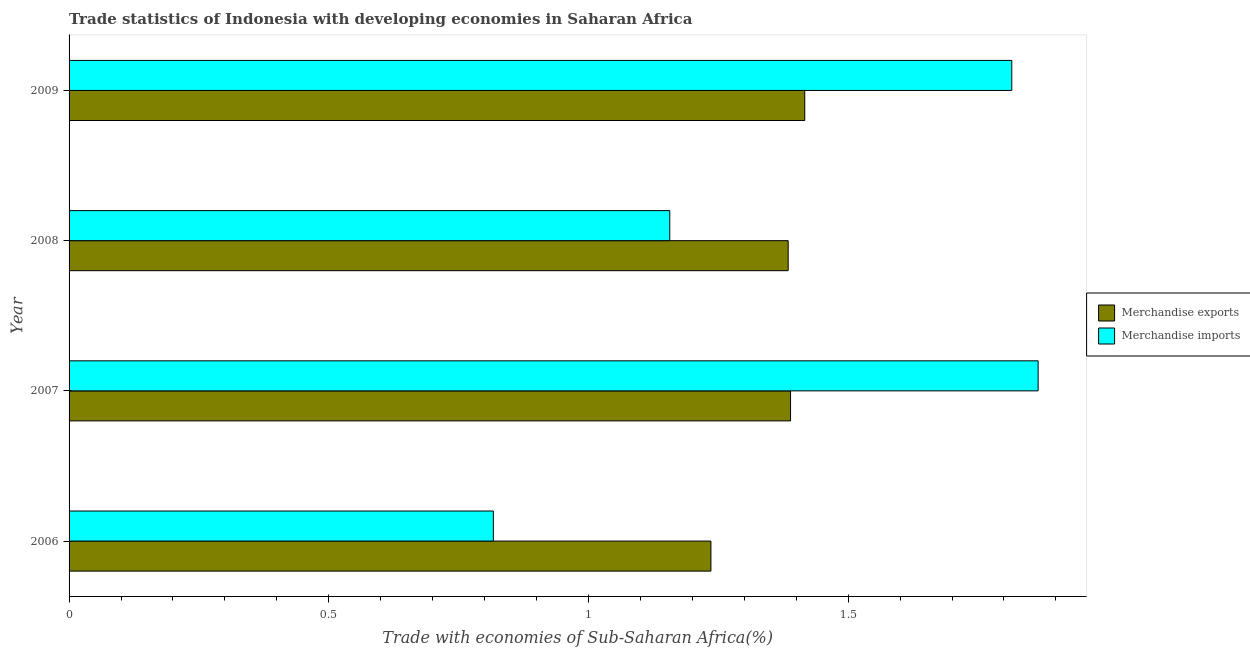How many groups of bars are there?
Your answer should be very brief. 4. Are the number of bars on each tick of the Y-axis equal?
Offer a terse response. Yes. How many bars are there on the 2nd tick from the top?
Offer a very short reply. 2. What is the label of the 3rd group of bars from the top?
Give a very brief answer. 2007. In how many cases, is the number of bars for a given year not equal to the number of legend labels?
Make the answer very short. 0. What is the merchandise exports in 2006?
Offer a terse response. 1.24. Across all years, what is the maximum merchandise imports?
Make the answer very short. 1.87. Across all years, what is the minimum merchandise imports?
Give a very brief answer. 0.82. In which year was the merchandise exports minimum?
Your answer should be compact. 2006. What is the total merchandise imports in the graph?
Your answer should be very brief. 5.65. What is the difference between the merchandise exports in 2006 and that in 2007?
Ensure brevity in your answer.  -0.15. What is the difference between the merchandise imports in 2009 and the merchandise exports in 2007?
Make the answer very short. 0.43. What is the average merchandise imports per year?
Keep it short and to the point. 1.41. In the year 2006, what is the difference between the merchandise imports and merchandise exports?
Provide a succinct answer. -0.42. What is the ratio of the merchandise imports in 2006 to that in 2008?
Your response must be concise. 0.71. What is the difference between the highest and the second highest merchandise exports?
Your answer should be compact. 0.03. What is the difference between the highest and the lowest merchandise exports?
Provide a succinct answer. 0.18. In how many years, is the merchandise exports greater than the average merchandise exports taken over all years?
Your response must be concise. 3. Is the sum of the merchandise exports in 2007 and 2008 greater than the maximum merchandise imports across all years?
Provide a short and direct response. Yes. What does the 2nd bar from the top in 2006 represents?
Your answer should be very brief. Merchandise exports. What does the 1st bar from the bottom in 2006 represents?
Offer a terse response. Merchandise exports. How many bars are there?
Ensure brevity in your answer.  8. Are all the bars in the graph horizontal?
Provide a succinct answer. Yes. Are the values on the major ticks of X-axis written in scientific E-notation?
Your response must be concise. No. Where does the legend appear in the graph?
Provide a succinct answer. Center right. How are the legend labels stacked?
Your answer should be very brief. Vertical. What is the title of the graph?
Keep it short and to the point. Trade statistics of Indonesia with developing economies in Saharan Africa. What is the label or title of the X-axis?
Offer a very short reply. Trade with economies of Sub-Saharan Africa(%). What is the label or title of the Y-axis?
Give a very brief answer. Year. What is the Trade with economies of Sub-Saharan Africa(%) in Merchandise exports in 2006?
Your answer should be very brief. 1.24. What is the Trade with economies of Sub-Saharan Africa(%) of Merchandise imports in 2006?
Offer a terse response. 0.82. What is the Trade with economies of Sub-Saharan Africa(%) of Merchandise exports in 2007?
Provide a short and direct response. 1.39. What is the Trade with economies of Sub-Saharan Africa(%) in Merchandise imports in 2007?
Give a very brief answer. 1.87. What is the Trade with economies of Sub-Saharan Africa(%) of Merchandise exports in 2008?
Keep it short and to the point. 1.38. What is the Trade with economies of Sub-Saharan Africa(%) of Merchandise imports in 2008?
Offer a very short reply. 1.16. What is the Trade with economies of Sub-Saharan Africa(%) of Merchandise exports in 2009?
Offer a very short reply. 1.42. What is the Trade with economies of Sub-Saharan Africa(%) in Merchandise imports in 2009?
Offer a very short reply. 1.82. Across all years, what is the maximum Trade with economies of Sub-Saharan Africa(%) of Merchandise exports?
Your answer should be very brief. 1.42. Across all years, what is the maximum Trade with economies of Sub-Saharan Africa(%) of Merchandise imports?
Your answer should be compact. 1.87. Across all years, what is the minimum Trade with economies of Sub-Saharan Africa(%) in Merchandise exports?
Your answer should be compact. 1.24. Across all years, what is the minimum Trade with economies of Sub-Saharan Africa(%) in Merchandise imports?
Keep it short and to the point. 0.82. What is the total Trade with economies of Sub-Saharan Africa(%) in Merchandise exports in the graph?
Provide a short and direct response. 5.43. What is the total Trade with economies of Sub-Saharan Africa(%) of Merchandise imports in the graph?
Your answer should be compact. 5.65. What is the difference between the Trade with economies of Sub-Saharan Africa(%) of Merchandise exports in 2006 and that in 2007?
Provide a succinct answer. -0.15. What is the difference between the Trade with economies of Sub-Saharan Africa(%) in Merchandise imports in 2006 and that in 2007?
Provide a succinct answer. -1.05. What is the difference between the Trade with economies of Sub-Saharan Africa(%) in Merchandise exports in 2006 and that in 2008?
Your answer should be very brief. -0.15. What is the difference between the Trade with economies of Sub-Saharan Africa(%) in Merchandise imports in 2006 and that in 2008?
Your answer should be compact. -0.34. What is the difference between the Trade with economies of Sub-Saharan Africa(%) of Merchandise exports in 2006 and that in 2009?
Your answer should be compact. -0.18. What is the difference between the Trade with economies of Sub-Saharan Africa(%) in Merchandise imports in 2006 and that in 2009?
Your answer should be compact. -1. What is the difference between the Trade with economies of Sub-Saharan Africa(%) of Merchandise exports in 2007 and that in 2008?
Ensure brevity in your answer.  0. What is the difference between the Trade with economies of Sub-Saharan Africa(%) of Merchandise imports in 2007 and that in 2008?
Make the answer very short. 0.71. What is the difference between the Trade with economies of Sub-Saharan Africa(%) of Merchandise exports in 2007 and that in 2009?
Give a very brief answer. -0.03. What is the difference between the Trade with economies of Sub-Saharan Africa(%) of Merchandise imports in 2007 and that in 2009?
Offer a very short reply. 0.05. What is the difference between the Trade with economies of Sub-Saharan Africa(%) in Merchandise exports in 2008 and that in 2009?
Offer a terse response. -0.03. What is the difference between the Trade with economies of Sub-Saharan Africa(%) of Merchandise imports in 2008 and that in 2009?
Give a very brief answer. -0.66. What is the difference between the Trade with economies of Sub-Saharan Africa(%) in Merchandise exports in 2006 and the Trade with economies of Sub-Saharan Africa(%) in Merchandise imports in 2007?
Provide a succinct answer. -0.63. What is the difference between the Trade with economies of Sub-Saharan Africa(%) in Merchandise exports in 2006 and the Trade with economies of Sub-Saharan Africa(%) in Merchandise imports in 2008?
Make the answer very short. 0.08. What is the difference between the Trade with economies of Sub-Saharan Africa(%) in Merchandise exports in 2006 and the Trade with economies of Sub-Saharan Africa(%) in Merchandise imports in 2009?
Provide a succinct answer. -0.58. What is the difference between the Trade with economies of Sub-Saharan Africa(%) in Merchandise exports in 2007 and the Trade with economies of Sub-Saharan Africa(%) in Merchandise imports in 2008?
Offer a terse response. 0.23. What is the difference between the Trade with economies of Sub-Saharan Africa(%) in Merchandise exports in 2007 and the Trade with economies of Sub-Saharan Africa(%) in Merchandise imports in 2009?
Provide a short and direct response. -0.43. What is the difference between the Trade with economies of Sub-Saharan Africa(%) in Merchandise exports in 2008 and the Trade with economies of Sub-Saharan Africa(%) in Merchandise imports in 2009?
Provide a short and direct response. -0.43. What is the average Trade with economies of Sub-Saharan Africa(%) in Merchandise exports per year?
Make the answer very short. 1.36. What is the average Trade with economies of Sub-Saharan Africa(%) in Merchandise imports per year?
Your answer should be compact. 1.41. In the year 2006, what is the difference between the Trade with economies of Sub-Saharan Africa(%) of Merchandise exports and Trade with economies of Sub-Saharan Africa(%) of Merchandise imports?
Give a very brief answer. 0.42. In the year 2007, what is the difference between the Trade with economies of Sub-Saharan Africa(%) in Merchandise exports and Trade with economies of Sub-Saharan Africa(%) in Merchandise imports?
Offer a terse response. -0.48. In the year 2008, what is the difference between the Trade with economies of Sub-Saharan Africa(%) of Merchandise exports and Trade with economies of Sub-Saharan Africa(%) of Merchandise imports?
Your response must be concise. 0.23. In the year 2009, what is the difference between the Trade with economies of Sub-Saharan Africa(%) in Merchandise exports and Trade with economies of Sub-Saharan Africa(%) in Merchandise imports?
Provide a short and direct response. -0.4. What is the ratio of the Trade with economies of Sub-Saharan Africa(%) of Merchandise exports in 2006 to that in 2007?
Offer a terse response. 0.89. What is the ratio of the Trade with economies of Sub-Saharan Africa(%) of Merchandise imports in 2006 to that in 2007?
Make the answer very short. 0.44. What is the ratio of the Trade with economies of Sub-Saharan Africa(%) of Merchandise exports in 2006 to that in 2008?
Offer a very short reply. 0.89. What is the ratio of the Trade with economies of Sub-Saharan Africa(%) of Merchandise imports in 2006 to that in 2008?
Keep it short and to the point. 0.71. What is the ratio of the Trade with economies of Sub-Saharan Africa(%) of Merchandise exports in 2006 to that in 2009?
Give a very brief answer. 0.87. What is the ratio of the Trade with economies of Sub-Saharan Africa(%) in Merchandise imports in 2006 to that in 2009?
Keep it short and to the point. 0.45. What is the ratio of the Trade with economies of Sub-Saharan Africa(%) in Merchandise exports in 2007 to that in 2008?
Keep it short and to the point. 1. What is the ratio of the Trade with economies of Sub-Saharan Africa(%) in Merchandise imports in 2007 to that in 2008?
Offer a terse response. 1.61. What is the ratio of the Trade with economies of Sub-Saharan Africa(%) in Merchandise exports in 2007 to that in 2009?
Ensure brevity in your answer.  0.98. What is the ratio of the Trade with economies of Sub-Saharan Africa(%) of Merchandise imports in 2007 to that in 2009?
Provide a short and direct response. 1.03. What is the ratio of the Trade with economies of Sub-Saharan Africa(%) in Merchandise exports in 2008 to that in 2009?
Your response must be concise. 0.98. What is the ratio of the Trade with economies of Sub-Saharan Africa(%) in Merchandise imports in 2008 to that in 2009?
Offer a very short reply. 0.64. What is the difference between the highest and the second highest Trade with economies of Sub-Saharan Africa(%) in Merchandise exports?
Your answer should be compact. 0.03. What is the difference between the highest and the second highest Trade with economies of Sub-Saharan Africa(%) in Merchandise imports?
Your answer should be compact. 0.05. What is the difference between the highest and the lowest Trade with economies of Sub-Saharan Africa(%) of Merchandise exports?
Ensure brevity in your answer.  0.18. What is the difference between the highest and the lowest Trade with economies of Sub-Saharan Africa(%) of Merchandise imports?
Offer a terse response. 1.05. 